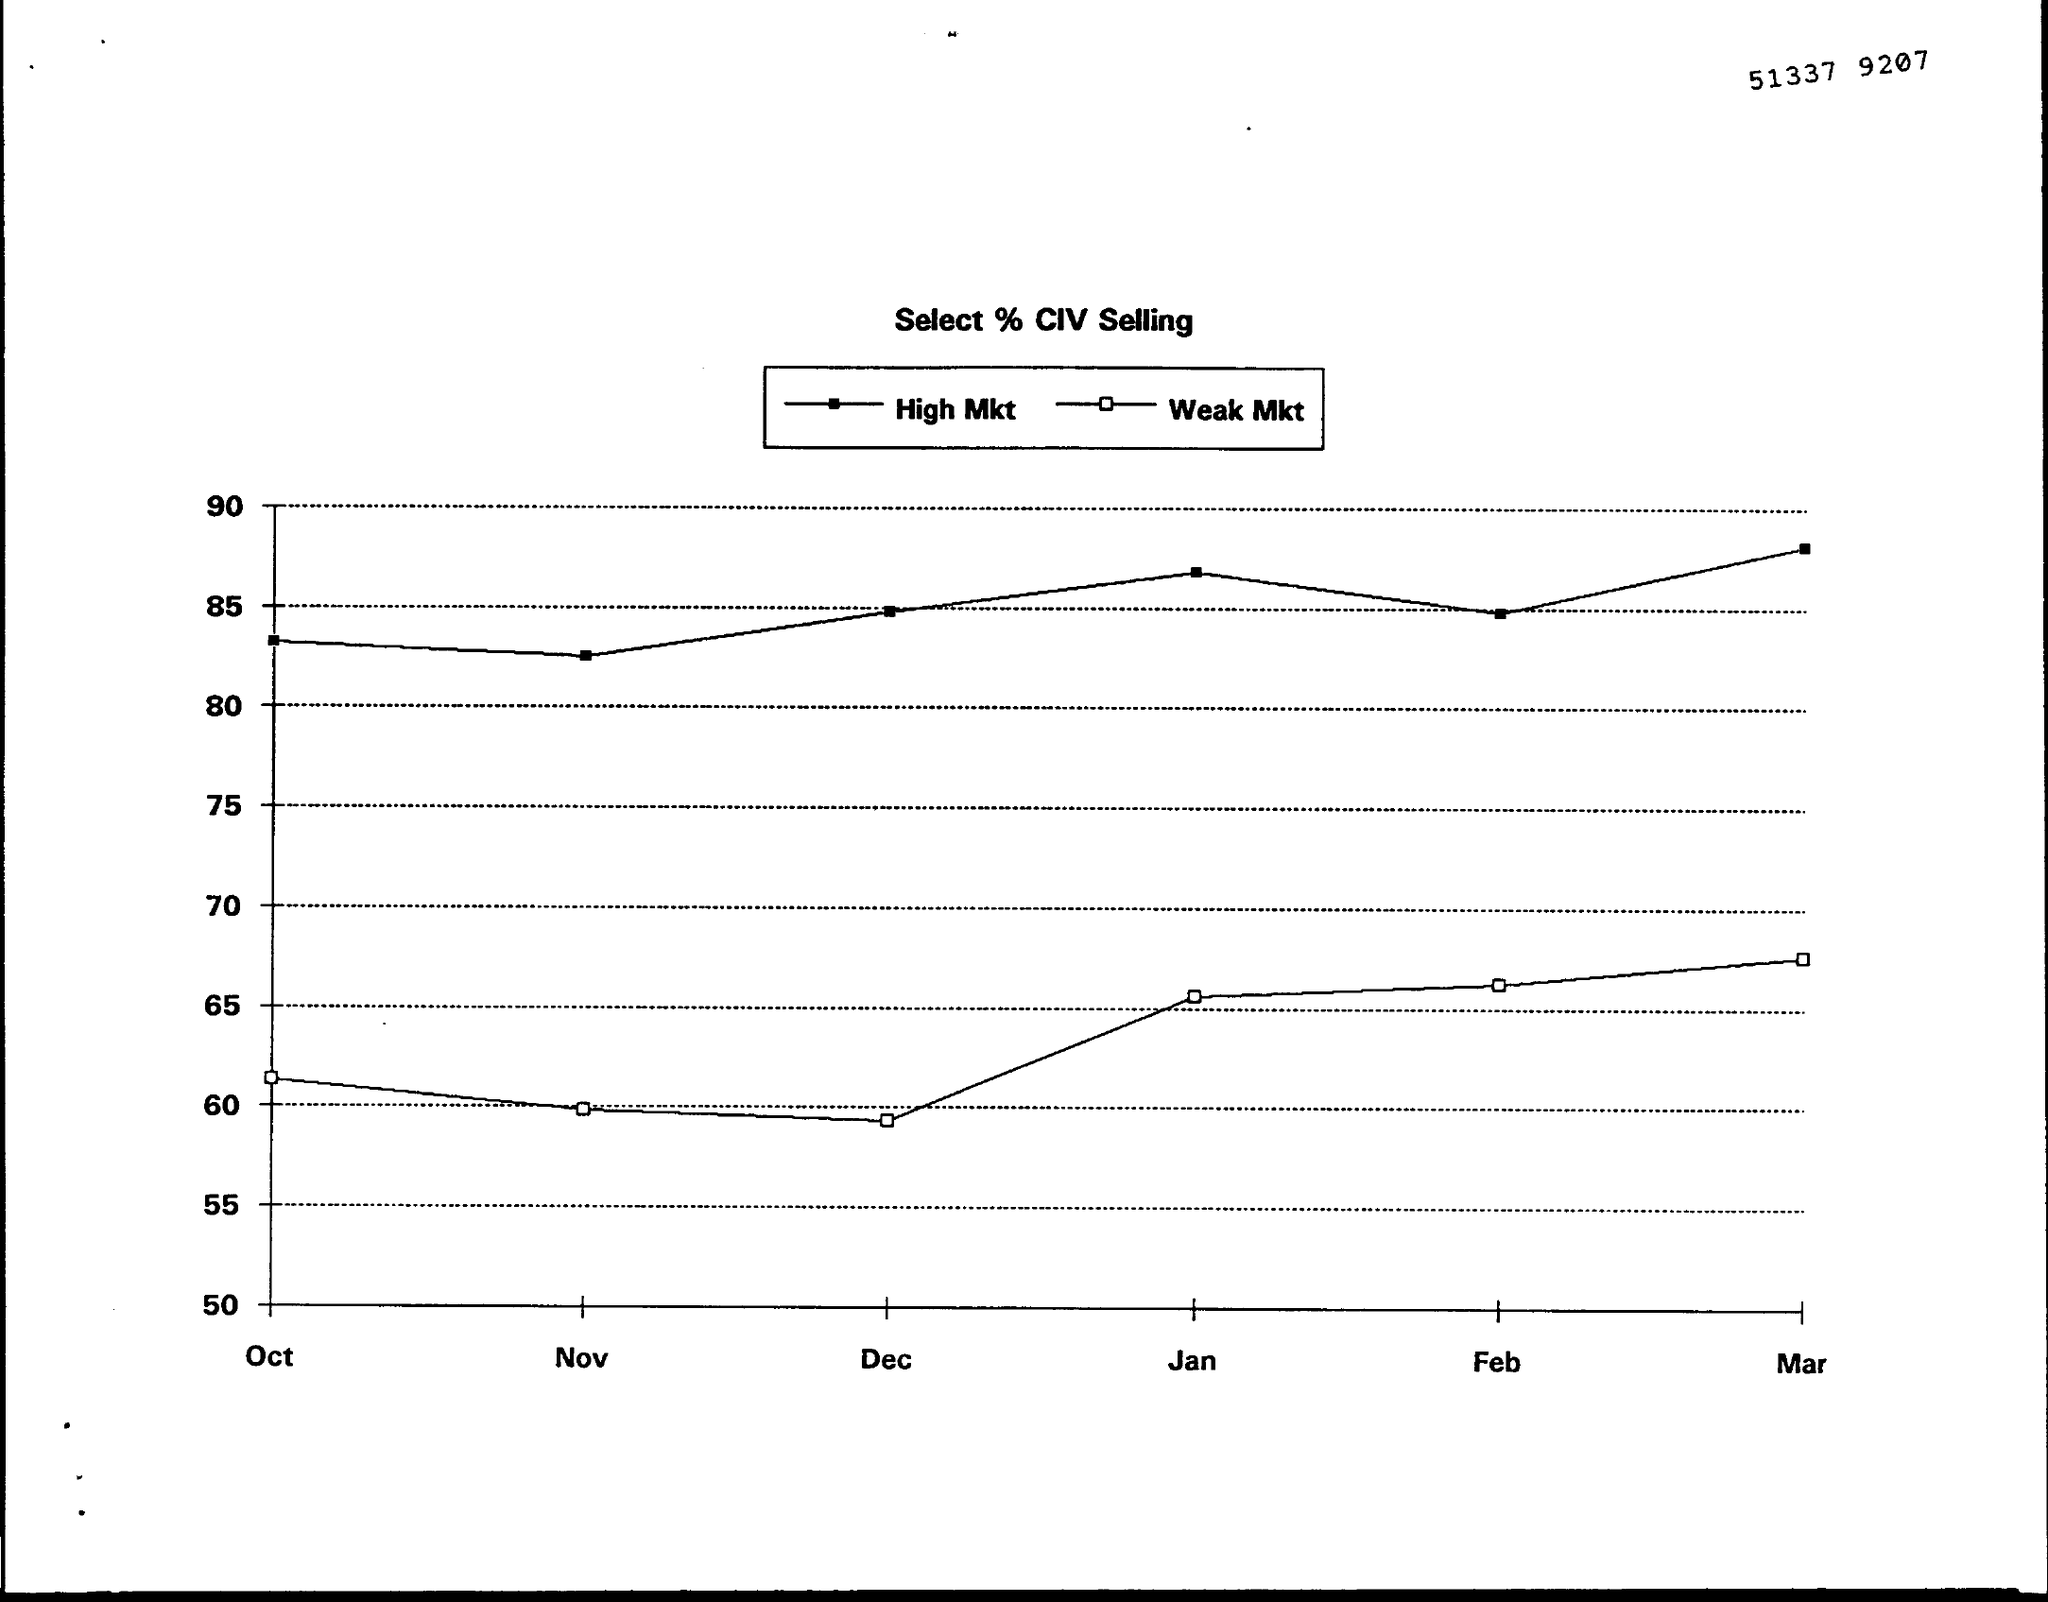What is the number written at the top of the page?
Give a very brief answer. 51337  9207. What is the title of the graph?
Ensure brevity in your answer.  Select % CIV Selling. 